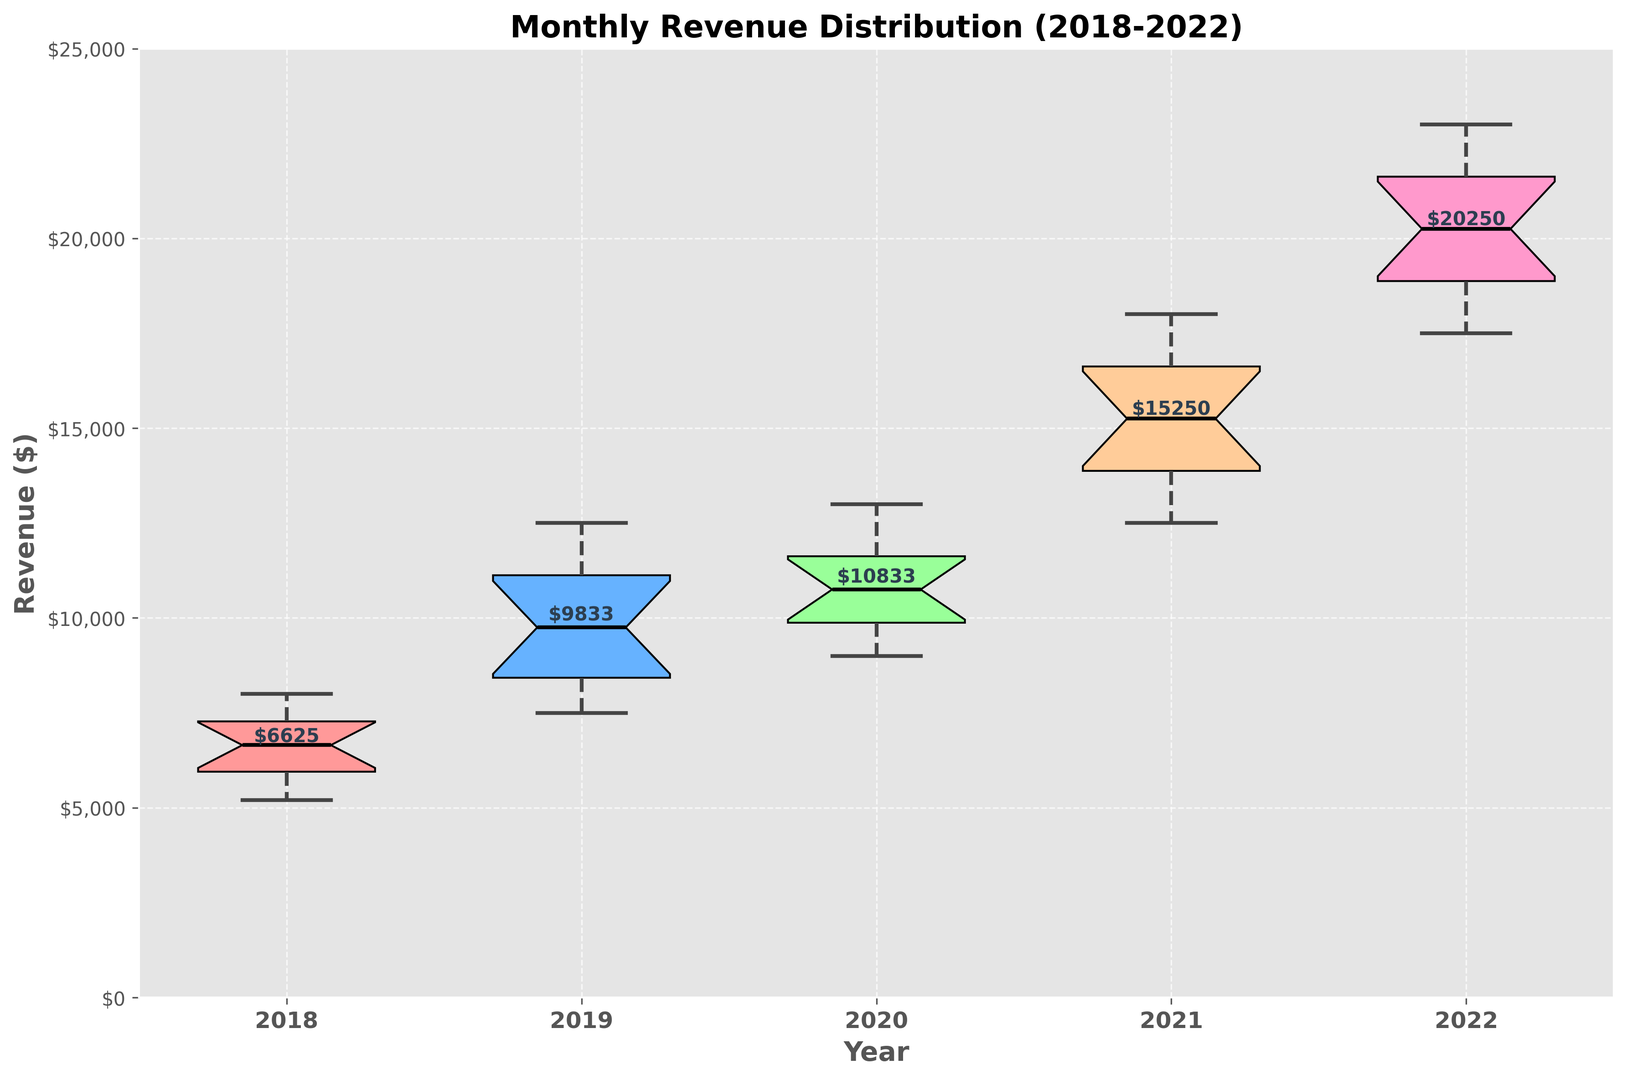What is the median monthly revenue for the year 2019? To find the median monthly revenue for the year 2019, locate the middle value in the revenue distribution of 2019 in the box plot, represented by the line inside the box.
Answer: $10,500 What was the highest revenue month in the year 2022? The highest revenue month is indicated by the upper whisker (or possibly an outlier) at the top of the box plot for the year 2022.
Answer: $23,000 How does the distribution of monthly revenues in 2020 compare to 2018 in terms of median revenue? Compare the median lines inside the boxes for the years 2020 and 2018. The median revenue for 2020 is higher than that for 2018.
Answer: 2020 is higher What is the interquartile range (IQR) for the year 2021? The IQR is calculated by subtracting the value at the Q1 (lower quartile) from the value at the Q3 (upper quartile). In the box plot, these are the lower and upper edges of the box.
Answer: $5,500 Which year had the smallest variation in monthly revenues? The year with the smallest variation has the shortest box length (indicating interquartile range) and shorter whiskers in the box plot.
Answer: 2018 Which year had the highest median monthly revenue? Look for the year with the highest median line within the box plot.
Answer: 2022 How did the revenue trend from 2018 to 2022 in terms of the median values? Track the changes in the median line of the box plot from year to year. The median value increased each year.
Answer: Increasing trend What was the approximate revenue range in 2018? The revenue range is the distance between the bottom of the lower whisker and the top of the upper whisker.
Answer: ~$5,200 to ~$8,000 Are there any outliers in the 2021 revenue distribution? If so, what are they? Outliers are represented by individual points outside the whiskers in the box plot. In 2021, there are no points outside the whiskers.
Answer: None 